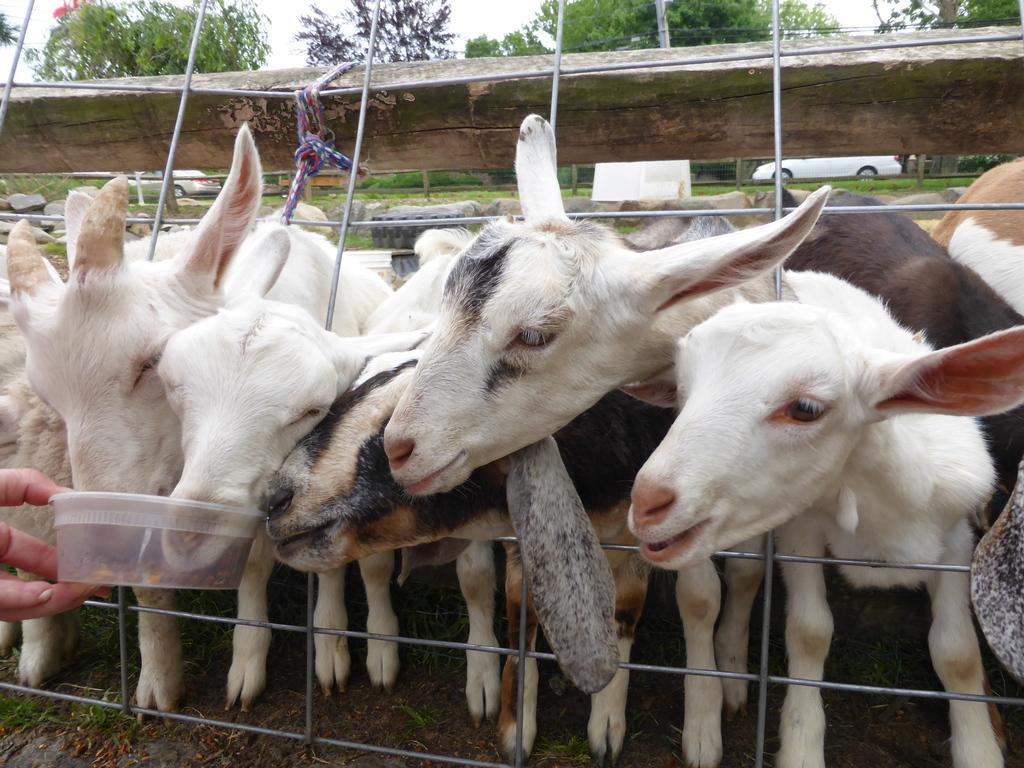Could you give a brief overview of what you see in this image? In this image there is a person's hand holding a plastic bowl with food is feeding the goats inside a closed mesh fence with wooden stick at the top, in the background of the image there are rocks, cars and trees. 